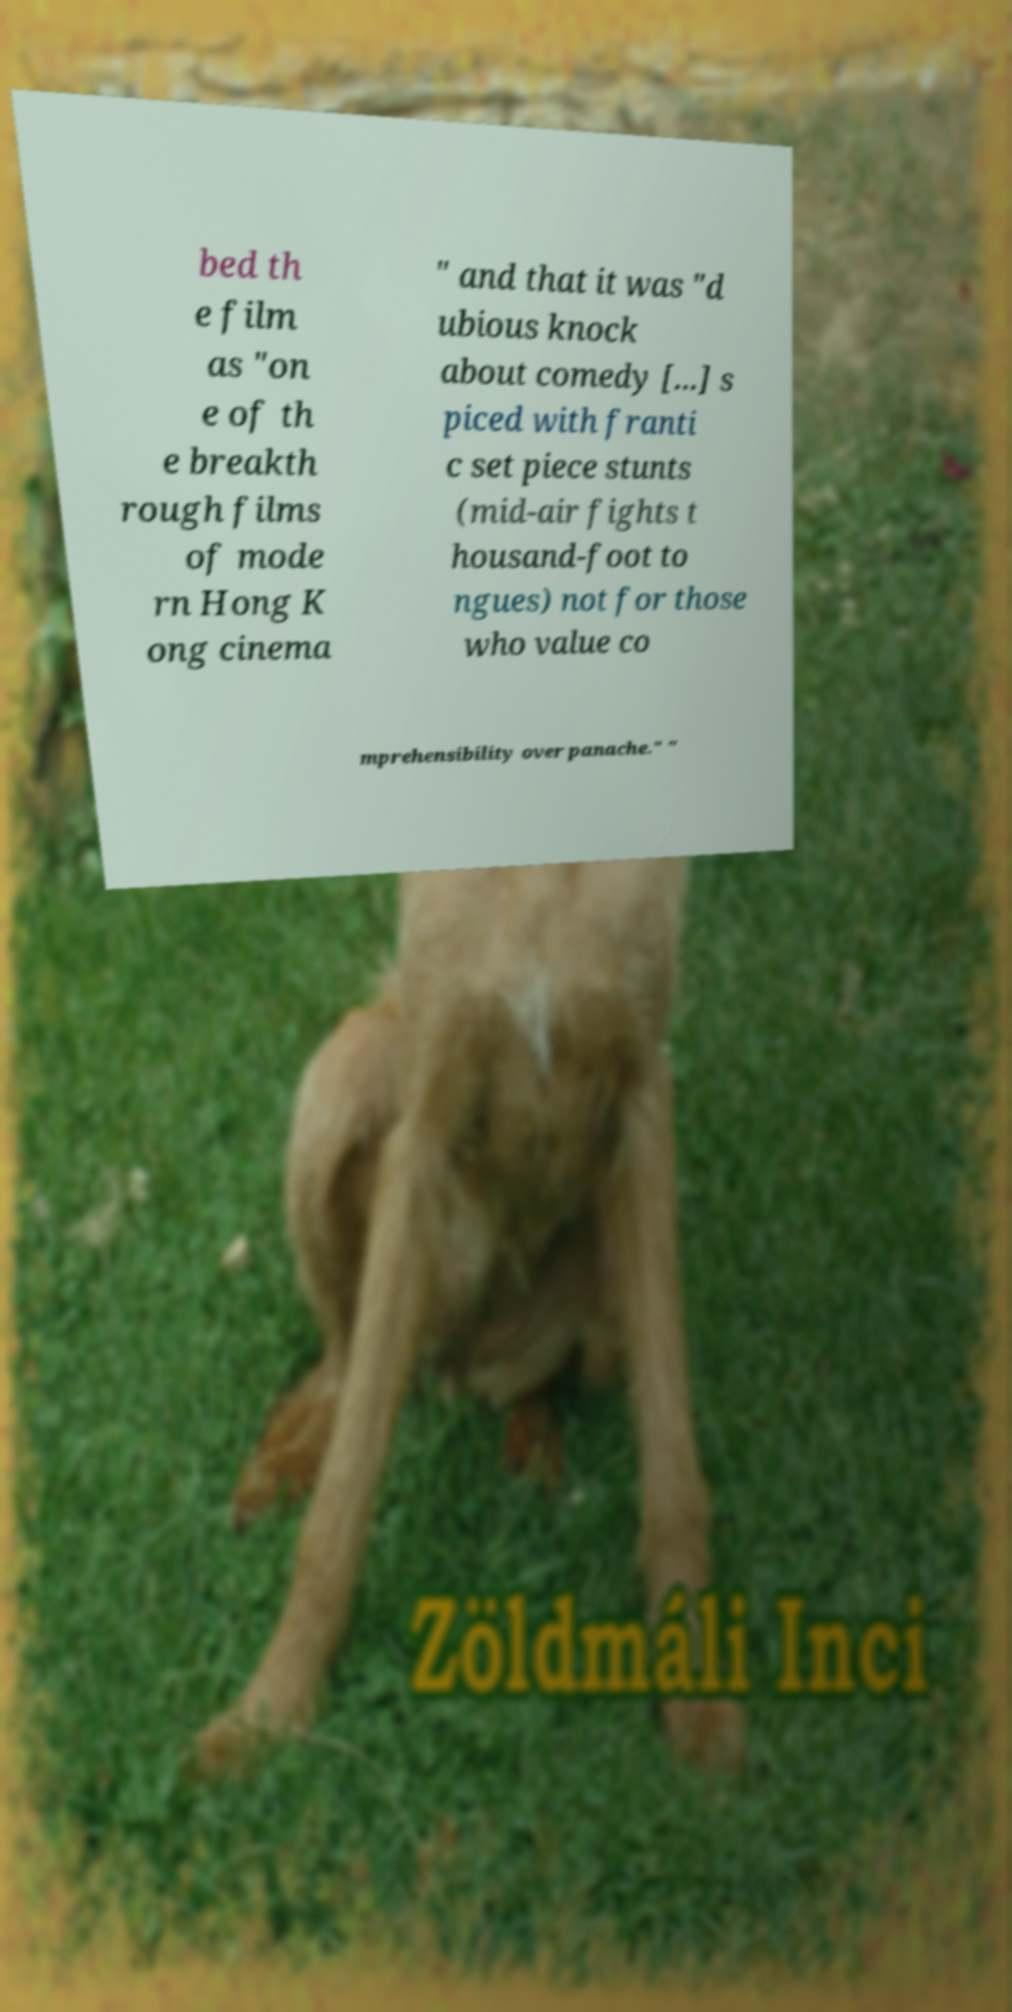Can you accurately transcribe the text from the provided image for me? bed th e film as "on e of th e breakth rough films of mode rn Hong K ong cinema " and that it was "d ubious knock about comedy [...] s piced with franti c set piece stunts (mid-air fights t housand-foot to ngues) not for those who value co mprehensibility over panache." " 